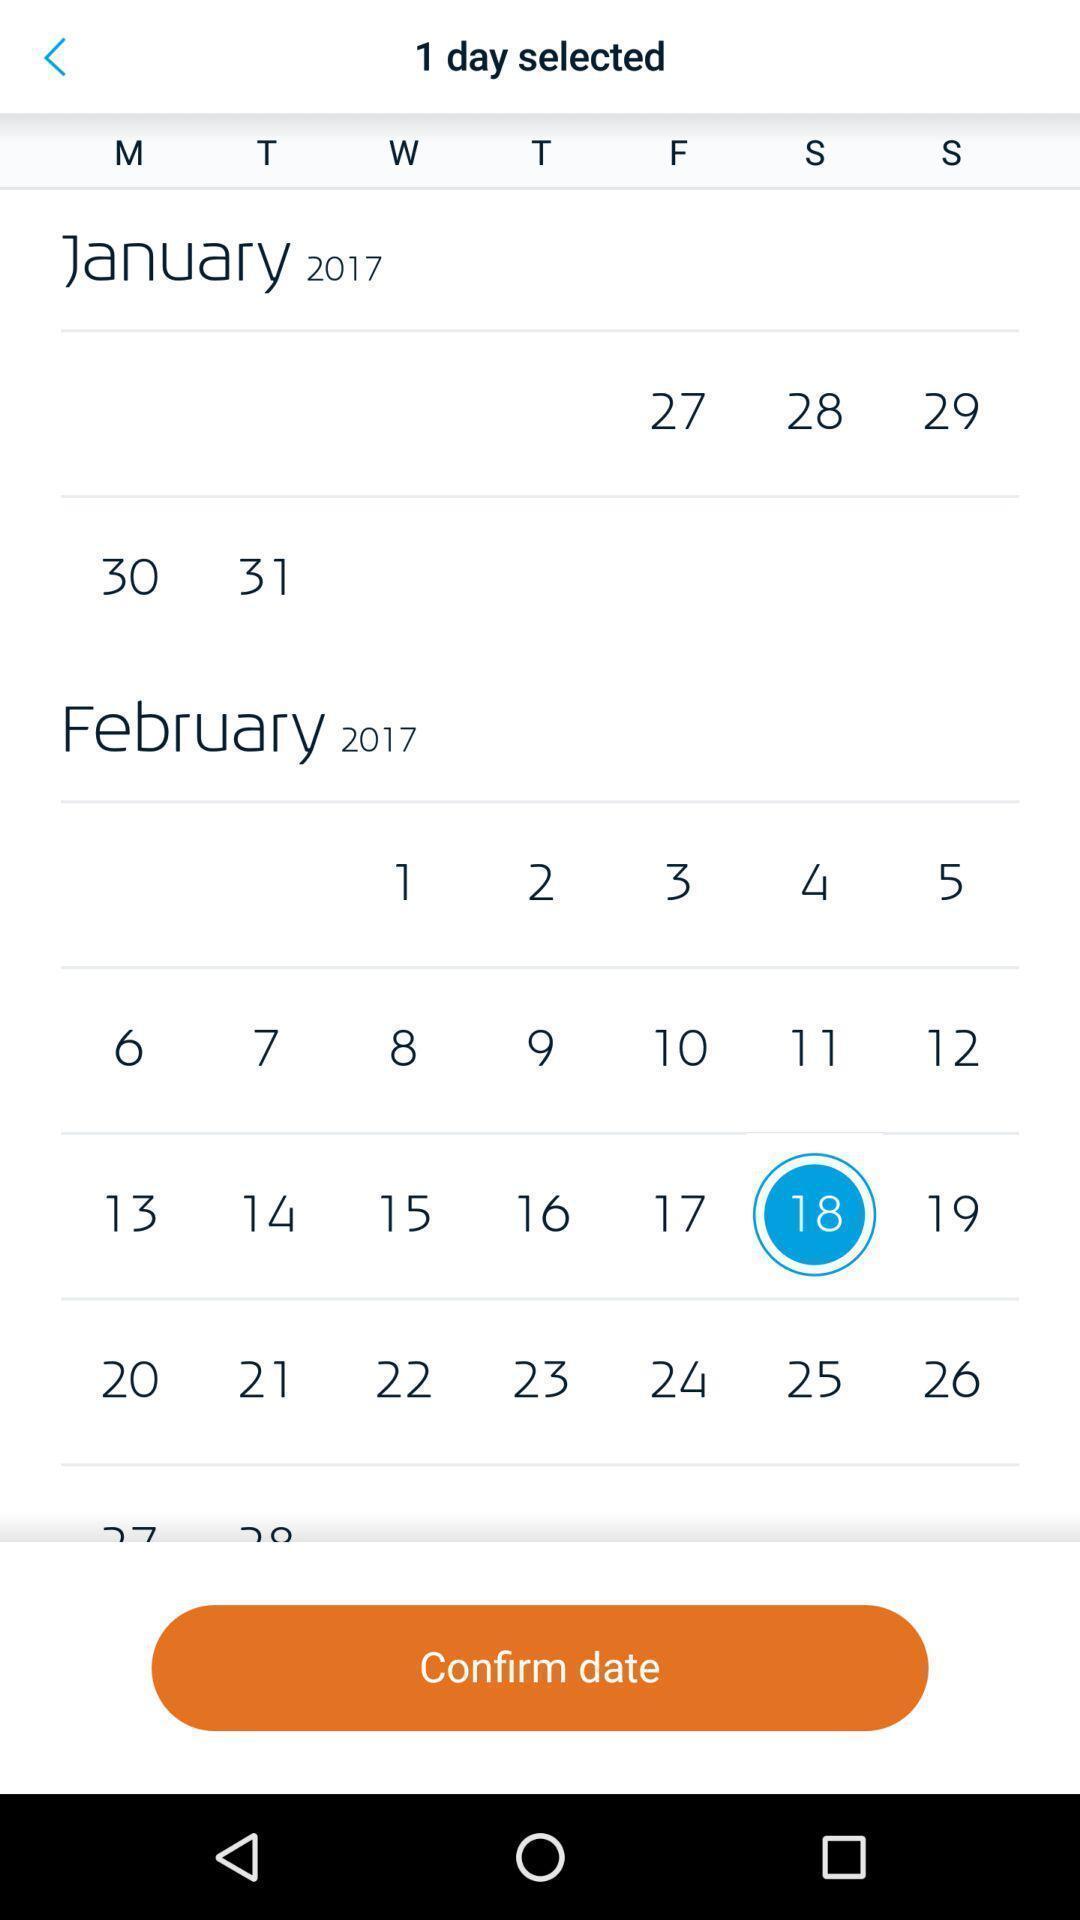Explain what's happening in this screen capture. Screen shows to confirm dates in a calendar app. 